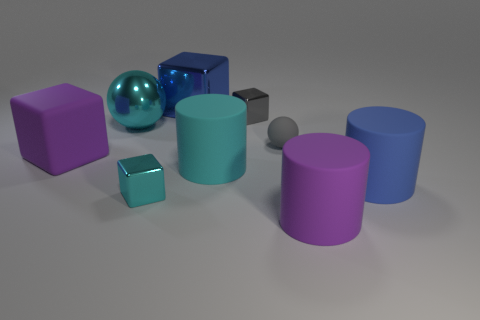What different shapes can you identify in this image? In the image, there are multiple geometric shapes present. Specifically, I can identify spheres, cubes, and cylinders. 